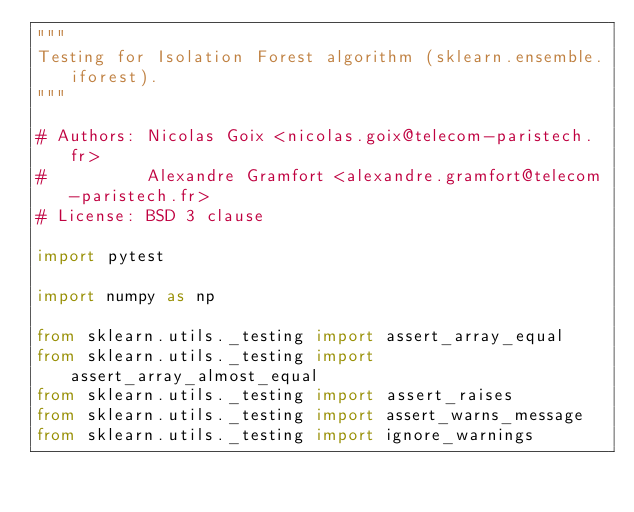Convert code to text. <code><loc_0><loc_0><loc_500><loc_500><_Python_>"""
Testing for Isolation Forest algorithm (sklearn.ensemble.iforest).
"""

# Authors: Nicolas Goix <nicolas.goix@telecom-paristech.fr>
#          Alexandre Gramfort <alexandre.gramfort@telecom-paristech.fr>
# License: BSD 3 clause

import pytest

import numpy as np

from sklearn.utils._testing import assert_array_equal
from sklearn.utils._testing import assert_array_almost_equal
from sklearn.utils._testing import assert_raises
from sklearn.utils._testing import assert_warns_message
from sklearn.utils._testing import ignore_warnings</code> 